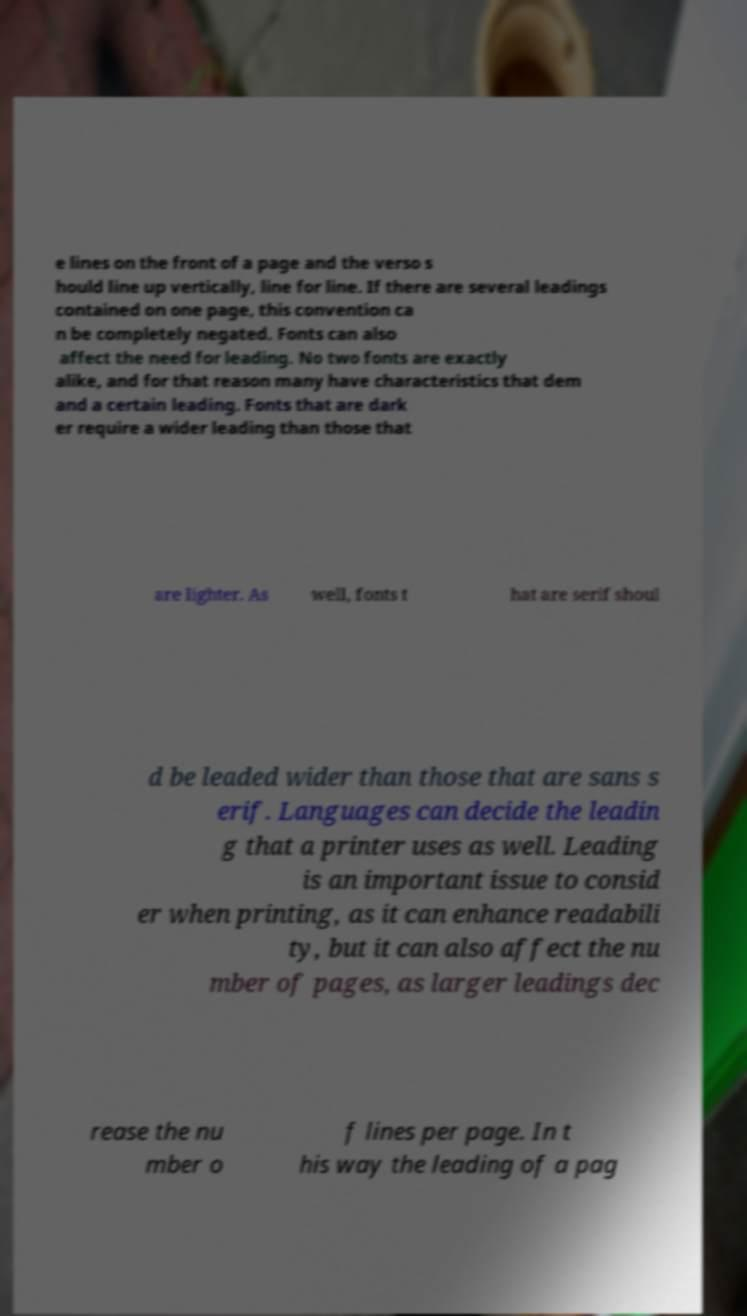For documentation purposes, I need the text within this image transcribed. Could you provide that? e lines on the front of a page and the verso s hould line up vertically, line for line. If there are several leadings contained on one page, this convention ca n be completely negated. Fonts can also affect the need for leading. No two fonts are exactly alike, and for that reason many have characteristics that dem and a certain leading. Fonts that are dark er require a wider leading than those that are lighter. As well, fonts t hat are serif shoul d be leaded wider than those that are sans s erif. Languages can decide the leadin g that a printer uses as well. Leading is an important issue to consid er when printing, as it can enhance readabili ty, but it can also affect the nu mber of pages, as larger leadings dec rease the nu mber o f lines per page. In t his way the leading of a pag 